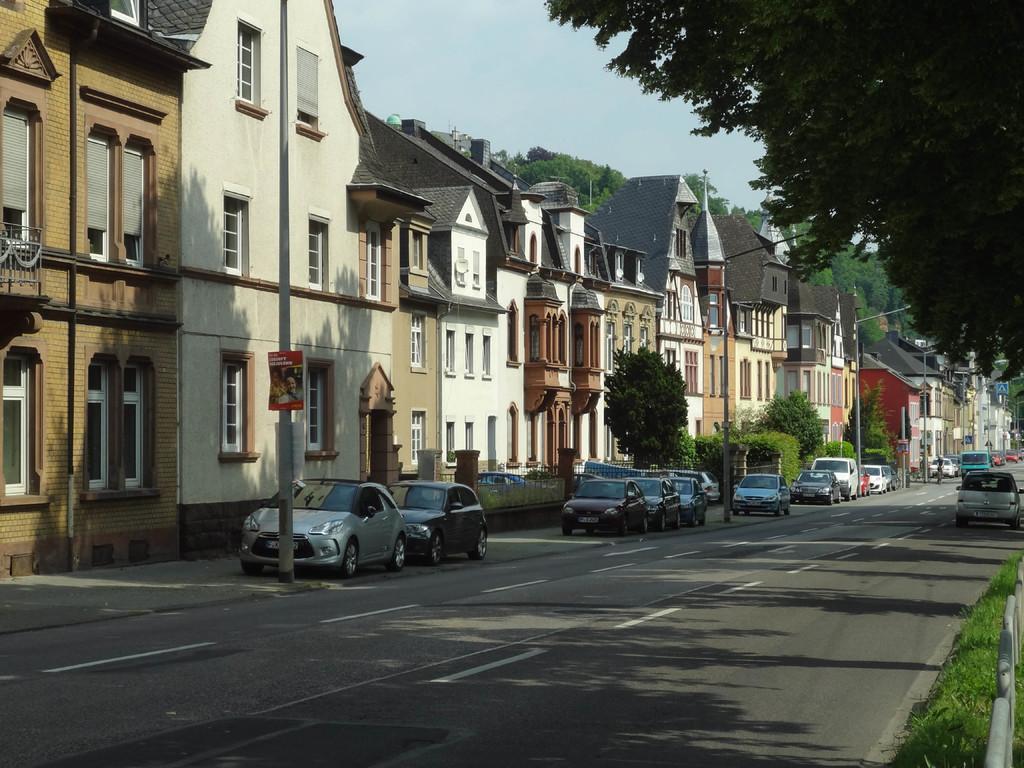Can you describe this image briefly? We can see grass,fences,buildings and vehicles on the road. We can see trees,boards on pole,poles and sky. 